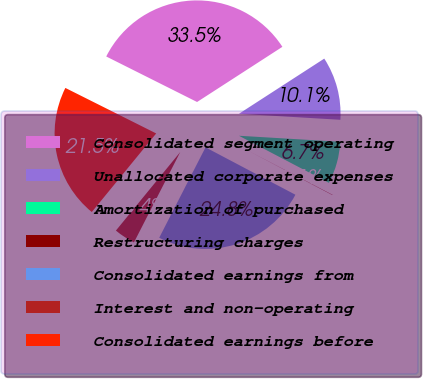<chart> <loc_0><loc_0><loc_500><loc_500><pie_chart><fcel>Consolidated segment operating<fcel>Unallocated corporate expenses<fcel>Amortization of purchased<fcel>Restructuring charges<fcel>Consolidated earnings from<fcel>Interest and non-operating<fcel>Consolidated earnings before<nl><fcel>33.47%<fcel>10.08%<fcel>6.73%<fcel>0.05%<fcel>24.81%<fcel>3.39%<fcel>21.47%<nl></chart> 